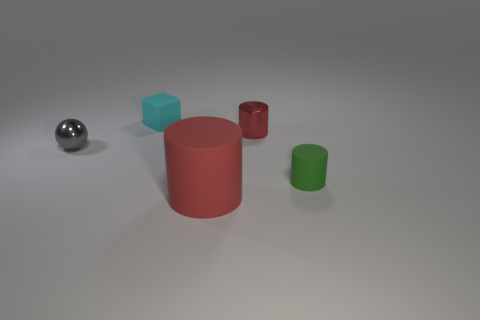Add 3 large red cylinders. How many objects exist? 8 Subtract all large matte cylinders. How many cylinders are left? 2 Subtract all green cylinders. How many cylinders are left? 2 Subtract all cylinders. How many objects are left? 2 Subtract 1 spheres. How many spheres are left? 0 Subtract all purple cylinders. Subtract all brown blocks. How many cylinders are left? 3 Subtract all gray spheres. How many green cylinders are left? 1 Subtract all large red cylinders. Subtract all small objects. How many objects are left? 0 Add 4 tiny cyan matte cubes. How many tiny cyan matte cubes are left? 5 Add 4 large green shiny cylinders. How many large green shiny cylinders exist? 4 